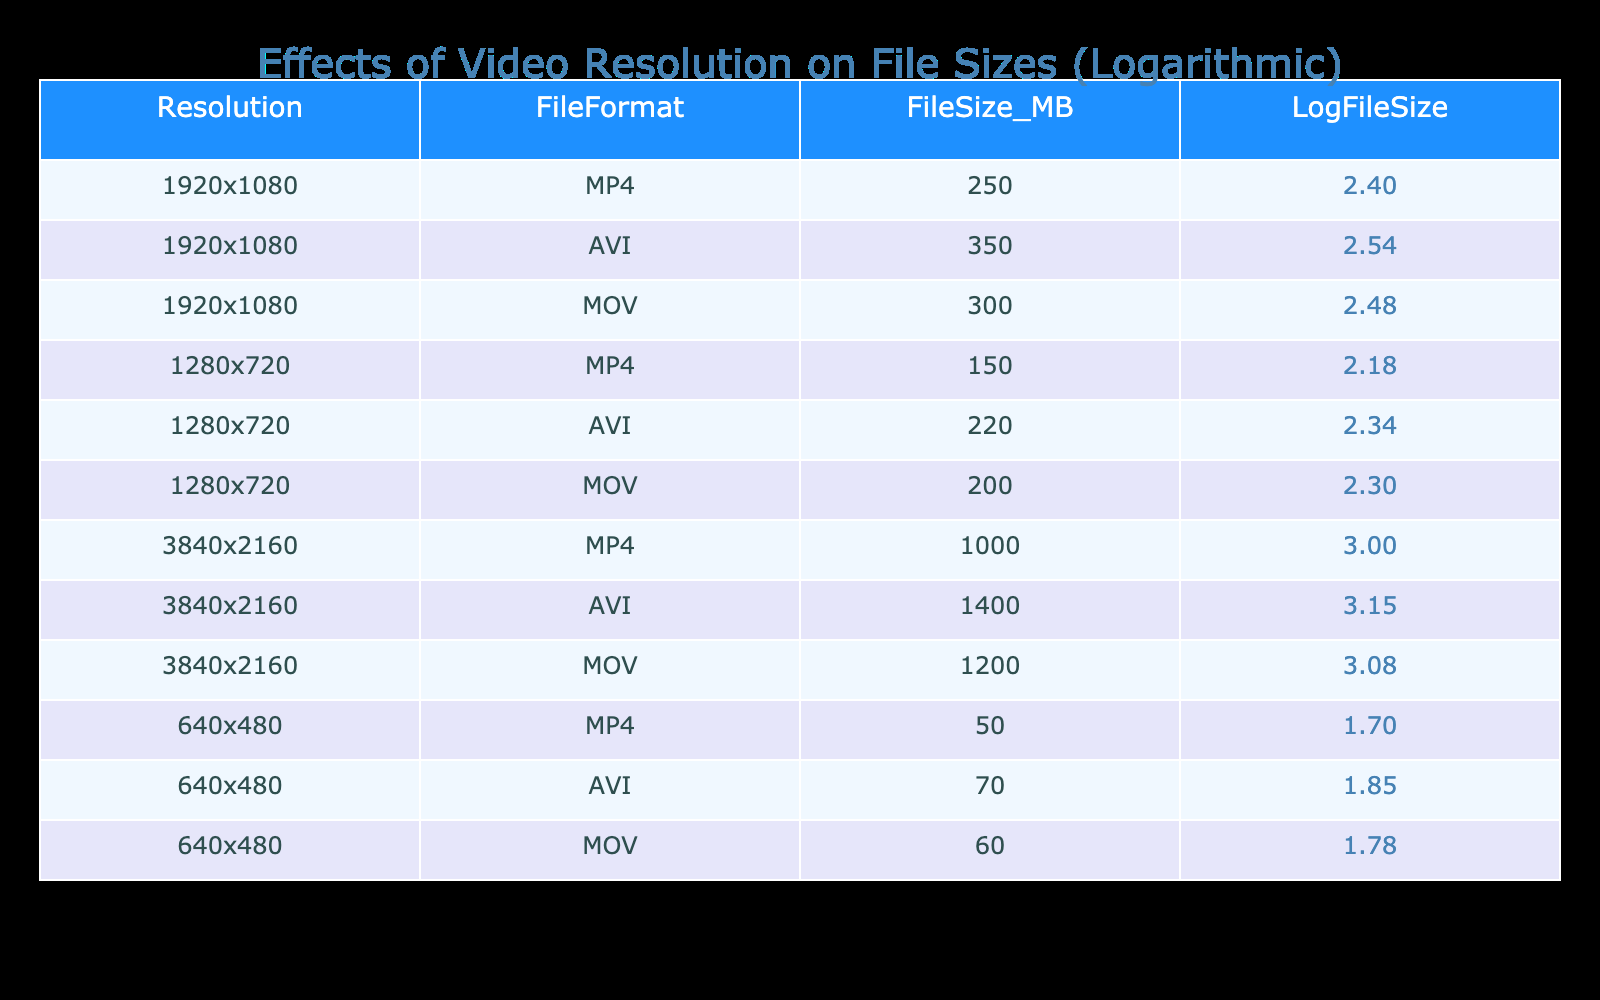What is the file size of a 1280x720 AVI video? From the table, I can find the row corresponding to the resolution 1280x720 and the file format AVI. The file size listed for this combination is 220 MB.
Answer: 220 MB Which file format has the largest file size at the resolution of 1920x1080? Looking at the rows for the resolution 1920x1080, I see the file sizes for each format: MP4 is 250 MB, AVI is 350 MB, and MOV is 300 MB. The largest file size here is for AVI.
Answer: AVI What is the difference in file size between the MP4 formats of 3840x2160 and 1920x1080? The file size for the MP4 format at 3840x2160 is 1000 MB, while for 1920x1080, it is 250 MB. To find the difference, I subtract: 1000 MB - 250 MB = 750 MB.
Answer: 750 MB Is the file size of a 640x480 MOV video less than 100 MB? The table shows the file size for the 640x480 MOV video is 60 MB. Since 60 MB is less than 100 MB, the answer is yes.
Answer: Yes What is the average file size for all formats at the resolution of 1280x720? For 1280x720, the file sizes are MP4 (150 MB), AVI (220 MB), and MOV (200 MB). To find the average, I sum these values: 150 + 220 + 200 = 570 MB, then divide by the number of formats (3): 570 MB / 3 = 190 MB.
Answer: 190 MB Which resolution files have a total combined size greater than 1700 MB? Let's calculate the total sizes for each resolution. For 1920x1080, the total is 250 + 350 + 300 = 900 MB. For 1280x720, it's 150 + 220 + 200 = 570 MB. For 3840x2160, it’s 1000 + 1400 + 1200 = 3600 MB. The only resolution with a total greater than 1700 MB is 3840x2160.
Answer: 3840x2160 Does the MOV format consistently have higher file sizes than the MP4 format across all resolutions? I need to compare the file sizes across all resolutions. For 1920x1080: MOV (300 MB) is greater than MP4 (250 MB). For 1280x720: MOV (200 MB) is greater than MP4 (150 MB). However, for 3840x2160: MOV (1200 MB) is still greater than MP4 (1000 MB). Thus, MOV consistently has higher sizes than MP4.
Answer: Yes What is the file size of the smallest resolution and format in the table? The smallest resolution shown is 640x480, with the smallest file size among different formats being MP4 at 50 MB.
Answer: 50 MB How much larger is the file size of a 3840x2160 AVI compared to a 1280x720 AVI? The file size for a 3840x2160 AVI is 1400 MB, and for 1280x720 AVI, it is 220 MB. The difference is calculated as 1400 MB - 220 MB = 1180 MB.
Answer: 1180 MB 